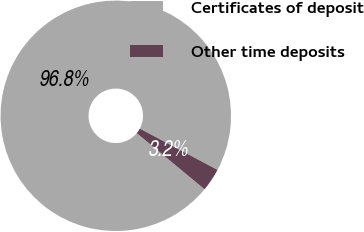Convert chart to OTSL. <chart><loc_0><loc_0><loc_500><loc_500><pie_chart><fcel>Certificates of deposit<fcel>Other time deposits<nl><fcel>96.78%<fcel>3.22%<nl></chart> 